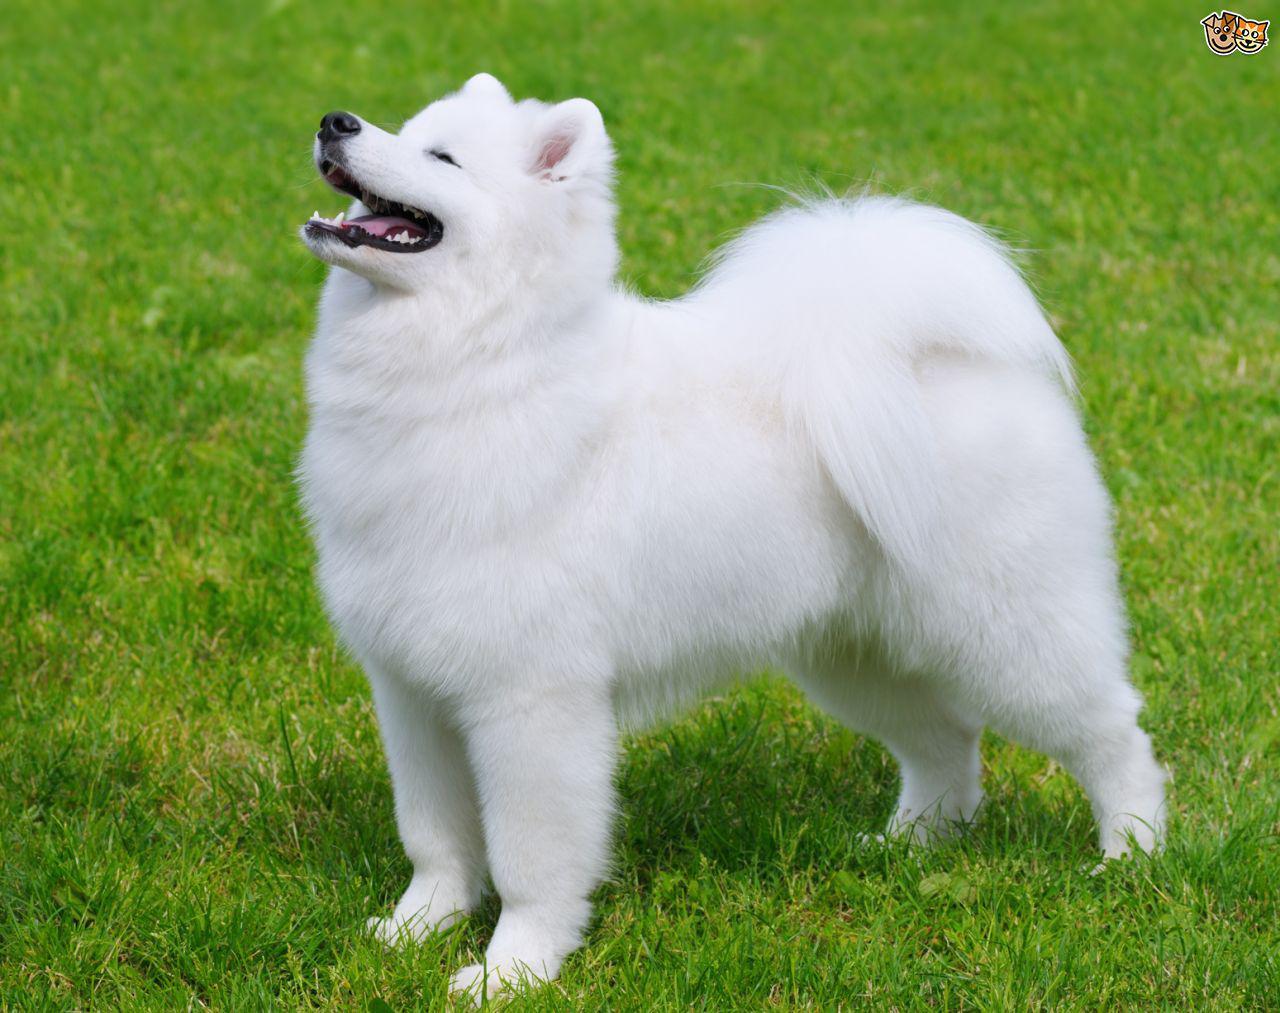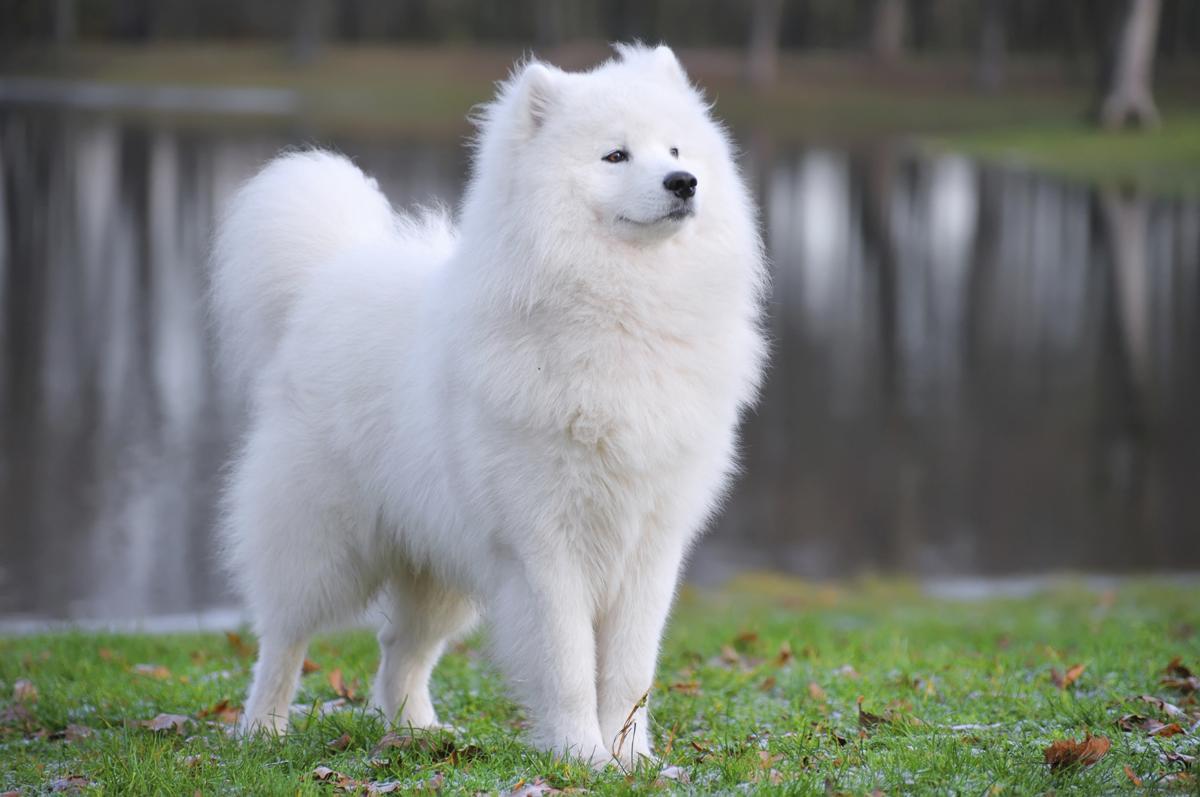The first image is the image on the left, the second image is the image on the right. Evaluate the accuracy of this statement regarding the images: "The dog on the right has its tongue sticking out.". Is it true? Answer yes or no. No. 